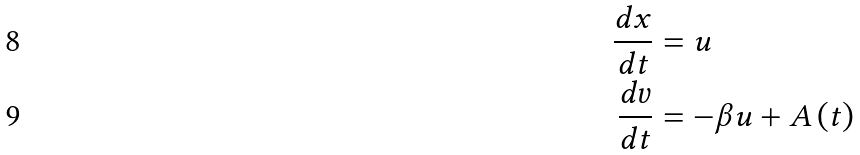Convert formula to latex. <formula><loc_0><loc_0><loc_500><loc_500>\frac { d x } { d t } & = u \\ \frac { d v } { d t } & = - \beta u + A \left ( t \right )</formula> 